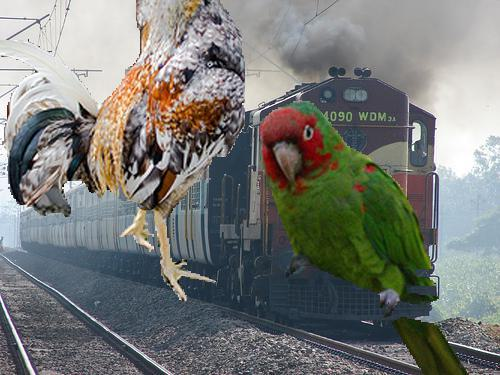How many unicorns would there be in the image if four additional unicorns were added in the scene? Given that there are no unicorns in the current image, adding four unicorns would result in a total of four unicorns whimsically superimposed onto the scene, assuming they could be placed without obscuring the existing animals or the train. 